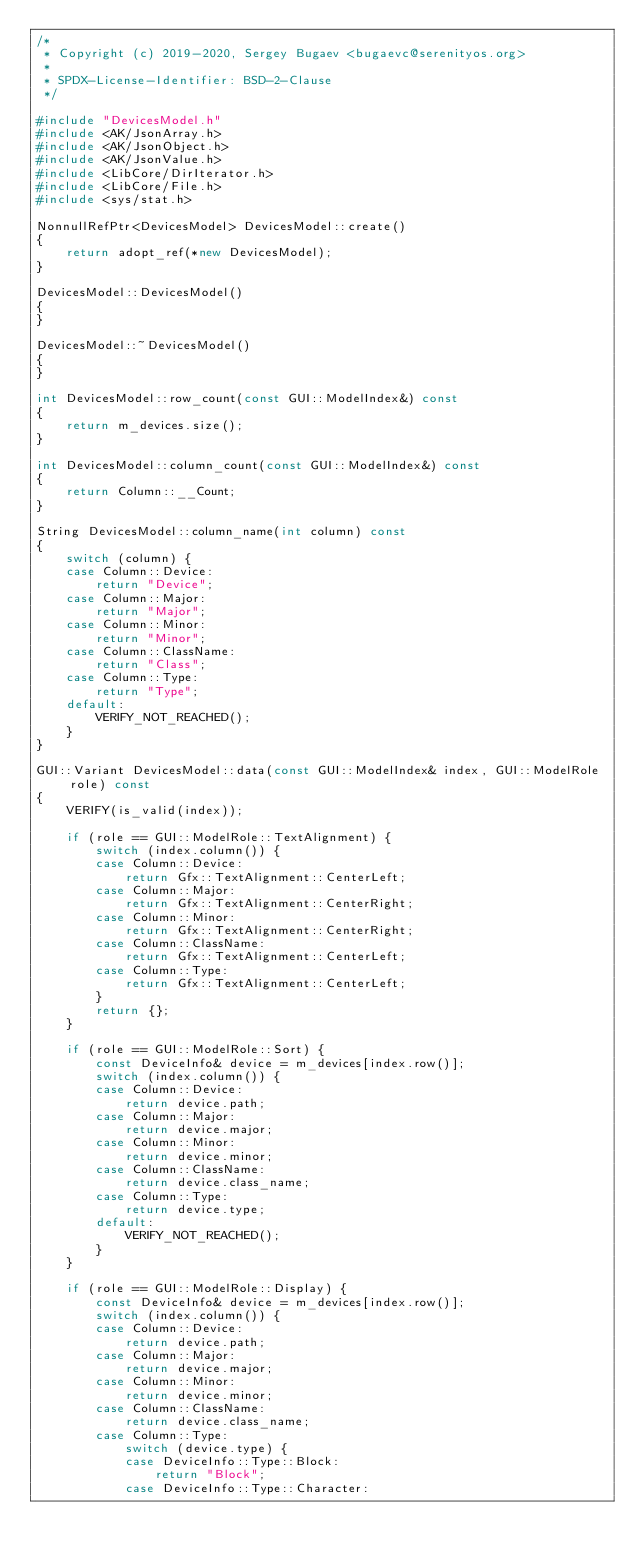<code> <loc_0><loc_0><loc_500><loc_500><_C++_>/*
 * Copyright (c) 2019-2020, Sergey Bugaev <bugaevc@serenityos.org>
 *
 * SPDX-License-Identifier: BSD-2-Clause
 */

#include "DevicesModel.h"
#include <AK/JsonArray.h>
#include <AK/JsonObject.h>
#include <AK/JsonValue.h>
#include <LibCore/DirIterator.h>
#include <LibCore/File.h>
#include <sys/stat.h>

NonnullRefPtr<DevicesModel> DevicesModel::create()
{
    return adopt_ref(*new DevicesModel);
}

DevicesModel::DevicesModel()
{
}

DevicesModel::~DevicesModel()
{
}

int DevicesModel::row_count(const GUI::ModelIndex&) const
{
    return m_devices.size();
}

int DevicesModel::column_count(const GUI::ModelIndex&) const
{
    return Column::__Count;
}

String DevicesModel::column_name(int column) const
{
    switch (column) {
    case Column::Device:
        return "Device";
    case Column::Major:
        return "Major";
    case Column::Minor:
        return "Minor";
    case Column::ClassName:
        return "Class";
    case Column::Type:
        return "Type";
    default:
        VERIFY_NOT_REACHED();
    }
}

GUI::Variant DevicesModel::data(const GUI::ModelIndex& index, GUI::ModelRole role) const
{
    VERIFY(is_valid(index));

    if (role == GUI::ModelRole::TextAlignment) {
        switch (index.column()) {
        case Column::Device:
            return Gfx::TextAlignment::CenterLeft;
        case Column::Major:
            return Gfx::TextAlignment::CenterRight;
        case Column::Minor:
            return Gfx::TextAlignment::CenterRight;
        case Column::ClassName:
            return Gfx::TextAlignment::CenterLeft;
        case Column::Type:
            return Gfx::TextAlignment::CenterLeft;
        }
        return {};
    }

    if (role == GUI::ModelRole::Sort) {
        const DeviceInfo& device = m_devices[index.row()];
        switch (index.column()) {
        case Column::Device:
            return device.path;
        case Column::Major:
            return device.major;
        case Column::Minor:
            return device.minor;
        case Column::ClassName:
            return device.class_name;
        case Column::Type:
            return device.type;
        default:
            VERIFY_NOT_REACHED();
        }
    }

    if (role == GUI::ModelRole::Display) {
        const DeviceInfo& device = m_devices[index.row()];
        switch (index.column()) {
        case Column::Device:
            return device.path;
        case Column::Major:
            return device.major;
        case Column::Minor:
            return device.minor;
        case Column::ClassName:
            return device.class_name;
        case Column::Type:
            switch (device.type) {
            case DeviceInfo::Type::Block:
                return "Block";
            case DeviceInfo::Type::Character:</code> 